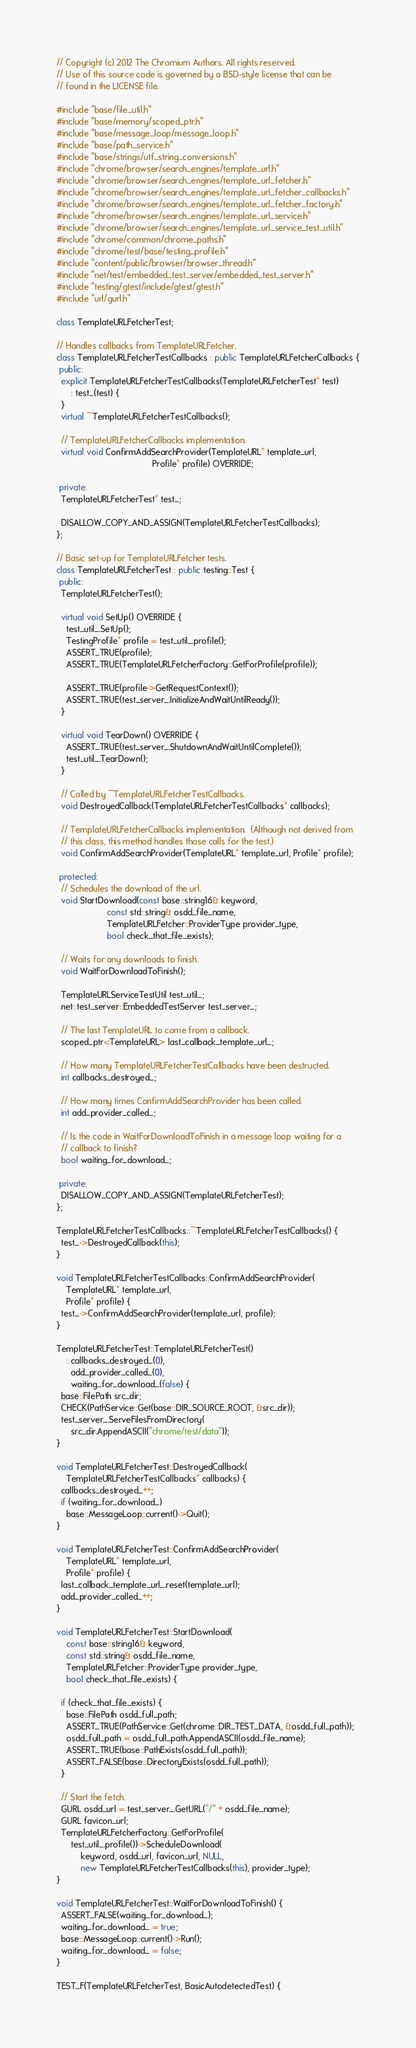<code> <loc_0><loc_0><loc_500><loc_500><_C++_>// Copyright (c) 2012 The Chromium Authors. All rights reserved.
// Use of this source code is governed by a BSD-style license that can be
// found in the LICENSE file.

#include "base/file_util.h"
#include "base/memory/scoped_ptr.h"
#include "base/message_loop/message_loop.h"
#include "base/path_service.h"
#include "base/strings/utf_string_conversions.h"
#include "chrome/browser/search_engines/template_url.h"
#include "chrome/browser/search_engines/template_url_fetcher.h"
#include "chrome/browser/search_engines/template_url_fetcher_callbacks.h"
#include "chrome/browser/search_engines/template_url_fetcher_factory.h"
#include "chrome/browser/search_engines/template_url_service.h"
#include "chrome/browser/search_engines/template_url_service_test_util.h"
#include "chrome/common/chrome_paths.h"
#include "chrome/test/base/testing_profile.h"
#include "content/public/browser/browser_thread.h"
#include "net/test/embedded_test_server/embedded_test_server.h"
#include "testing/gtest/include/gtest/gtest.h"
#include "url/gurl.h"

class TemplateURLFetcherTest;

// Handles callbacks from TemplateURLFetcher.
class TemplateURLFetcherTestCallbacks : public TemplateURLFetcherCallbacks {
 public:
  explicit TemplateURLFetcherTestCallbacks(TemplateURLFetcherTest* test)
      : test_(test) {
  }
  virtual ~TemplateURLFetcherTestCallbacks();

  // TemplateURLFetcherCallbacks implementation.
  virtual void ConfirmAddSearchProvider(TemplateURL* template_url,
                                        Profile* profile) OVERRIDE;

 private:
  TemplateURLFetcherTest* test_;

  DISALLOW_COPY_AND_ASSIGN(TemplateURLFetcherTestCallbacks);
};

// Basic set-up for TemplateURLFetcher tests.
class TemplateURLFetcherTest : public testing::Test {
 public:
  TemplateURLFetcherTest();

  virtual void SetUp() OVERRIDE {
    test_util_.SetUp();
    TestingProfile* profile = test_util_.profile();
    ASSERT_TRUE(profile);
    ASSERT_TRUE(TemplateURLFetcherFactory::GetForProfile(profile));

    ASSERT_TRUE(profile->GetRequestContext());
    ASSERT_TRUE(test_server_.InitializeAndWaitUntilReady());
  }

  virtual void TearDown() OVERRIDE {
    ASSERT_TRUE(test_server_.ShutdownAndWaitUntilComplete());
    test_util_.TearDown();
  }

  // Called by ~TemplateURLFetcherTestCallbacks.
  void DestroyedCallback(TemplateURLFetcherTestCallbacks* callbacks);

  // TemplateURLFetcherCallbacks implementation.  (Although not derived from
  // this class, this method handles those calls for the test.)
  void ConfirmAddSearchProvider(TemplateURL* template_url, Profile* profile);

 protected:
  // Schedules the download of the url.
  void StartDownload(const base::string16& keyword,
                     const std::string& osdd_file_name,
                     TemplateURLFetcher::ProviderType provider_type,
                     bool check_that_file_exists);

  // Waits for any downloads to finish.
  void WaitForDownloadToFinish();

  TemplateURLServiceTestUtil test_util_;
  net::test_server::EmbeddedTestServer test_server_;

  // The last TemplateURL to come from a callback.
  scoped_ptr<TemplateURL> last_callback_template_url_;

  // How many TemplateURLFetcherTestCallbacks have been destructed.
  int callbacks_destroyed_;

  // How many times ConfirmAddSearchProvider has been called.
  int add_provider_called_;

  // Is the code in WaitForDownloadToFinish in a message loop waiting for a
  // callback to finish?
  bool waiting_for_download_;

 private:
  DISALLOW_COPY_AND_ASSIGN(TemplateURLFetcherTest);
};

TemplateURLFetcherTestCallbacks::~TemplateURLFetcherTestCallbacks() {
  test_->DestroyedCallback(this);
}

void TemplateURLFetcherTestCallbacks::ConfirmAddSearchProvider(
    TemplateURL* template_url,
    Profile* profile) {
  test_->ConfirmAddSearchProvider(template_url, profile);
}

TemplateURLFetcherTest::TemplateURLFetcherTest()
    : callbacks_destroyed_(0),
      add_provider_called_(0),
      waiting_for_download_(false) {
  base::FilePath src_dir;
  CHECK(PathService::Get(base::DIR_SOURCE_ROOT, &src_dir));
  test_server_.ServeFilesFromDirectory(
      src_dir.AppendASCII("chrome/test/data"));
}

void TemplateURLFetcherTest::DestroyedCallback(
    TemplateURLFetcherTestCallbacks* callbacks) {
  callbacks_destroyed_++;
  if (waiting_for_download_)
    base::MessageLoop::current()->Quit();
}

void TemplateURLFetcherTest::ConfirmAddSearchProvider(
    TemplateURL* template_url,
    Profile* profile) {
  last_callback_template_url_.reset(template_url);
  add_provider_called_++;
}

void TemplateURLFetcherTest::StartDownload(
    const base::string16& keyword,
    const std::string& osdd_file_name,
    TemplateURLFetcher::ProviderType provider_type,
    bool check_that_file_exists) {

  if (check_that_file_exists) {
    base::FilePath osdd_full_path;
    ASSERT_TRUE(PathService::Get(chrome::DIR_TEST_DATA, &osdd_full_path));
    osdd_full_path = osdd_full_path.AppendASCII(osdd_file_name);
    ASSERT_TRUE(base::PathExists(osdd_full_path));
    ASSERT_FALSE(base::DirectoryExists(osdd_full_path));
  }

  // Start the fetch.
  GURL osdd_url = test_server_.GetURL("/" + osdd_file_name);
  GURL favicon_url;
  TemplateURLFetcherFactory::GetForProfile(
      test_util_.profile())->ScheduleDownload(
          keyword, osdd_url, favicon_url, NULL,
          new TemplateURLFetcherTestCallbacks(this), provider_type);
}

void TemplateURLFetcherTest::WaitForDownloadToFinish() {
  ASSERT_FALSE(waiting_for_download_);
  waiting_for_download_ = true;
  base::MessageLoop::current()->Run();
  waiting_for_download_ = false;
}

TEST_F(TemplateURLFetcherTest, BasicAutodetectedTest) {</code> 